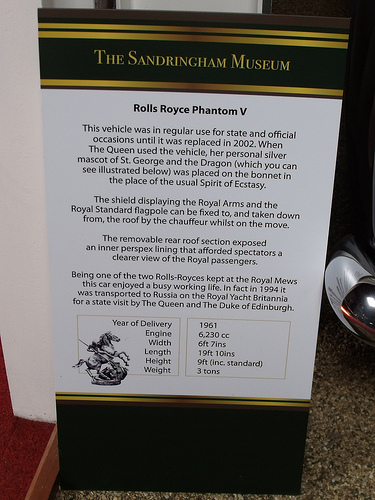<image>
Is the paper in front of the floor? No. The paper is not in front of the floor. The spatial positioning shows a different relationship between these objects. 